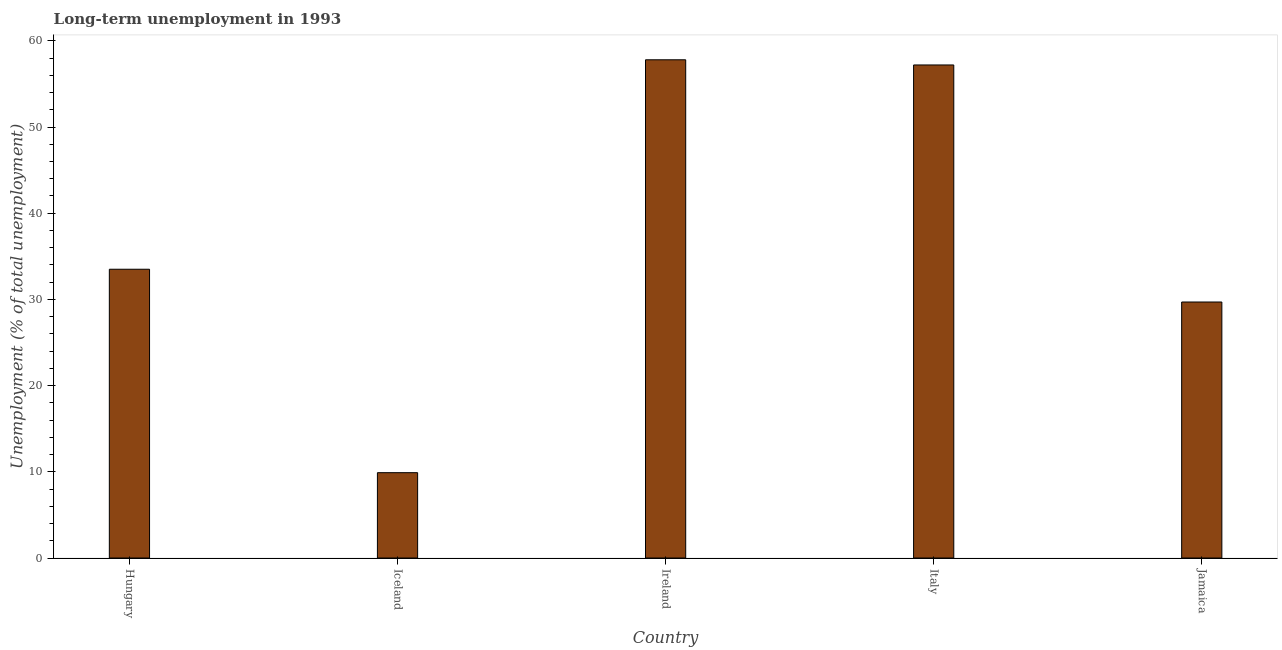Does the graph contain any zero values?
Offer a very short reply. No. Does the graph contain grids?
Your response must be concise. No. What is the title of the graph?
Your response must be concise. Long-term unemployment in 1993. What is the label or title of the X-axis?
Offer a terse response. Country. What is the label or title of the Y-axis?
Your response must be concise. Unemployment (% of total unemployment). What is the long-term unemployment in Jamaica?
Make the answer very short. 29.7. Across all countries, what is the maximum long-term unemployment?
Your answer should be very brief. 57.8. Across all countries, what is the minimum long-term unemployment?
Keep it short and to the point. 9.9. In which country was the long-term unemployment maximum?
Your answer should be very brief. Ireland. In which country was the long-term unemployment minimum?
Give a very brief answer. Iceland. What is the sum of the long-term unemployment?
Keep it short and to the point. 188.1. What is the difference between the long-term unemployment in Iceland and Italy?
Your response must be concise. -47.3. What is the average long-term unemployment per country?
Your response must be concise. 37.62. What is the median long-term unemployment?
Keep it short and to the point. 33.5. In how many countries, is the long-term unemployment greater than 18 %?
Your answer should be very brief. 4. What is the ratio of the long-term unemployment in Italy to that in Jamaica?
Make the answer very short. 1.93. What is the difference between the highest and the second highest long-term unemployment?
Provide a succinct answer. 0.6. Is the sum of the long-term unemployment in Hungary and Iceland greater than the maximum long-term unemployment across all countries?
Make the answer very short. No. What is the difference between the highest and the lowest long-term unemployment?
Ensure brevity in your answer.  47.9. In how many countries, is the long-term unemployment greater than the average long-term unemployment taken over all countries?
Make the answer very short. 2. How many countries are there in the graph?
Give a very brief answer. 5. What is the difference between two consecutive major ticks on the Y-axis?
Give a very brief answer. 10. What is the Unemployment (% of total unemployment) in Hungary?
Provide a short and direct response. 33.5. What is the Unemployment (% of total unemployment) of Iceland?
Your answer should be compact. 9.9. What is the Unemployment (% of total unemployment) of Ireland?
Provide a succinct answer. 57.8. What is the Unemployment (% of total unemployment) of Italy?
Make the answer very short. 57.2. What is the Unemployment (% of total unemployment) in Jamaica?
Keep it short and to the point. 29.7. What is the difference between the Unemployment (% of total unemployment) in Hungary and Iceland?
Give a very brief answer. 23.6. What is the difference between the Unemployment (% of total unemployment) in Hungary and Ireland?
Offer a very short reply. -24.3. What is the difference between the Unemployment (% of total unemployment) in Hungary and Italy?
Provide a succinct answer. -23.7. What is the difference between the Unemployment (% of total unemployment) in Hungary and Jamaica?
Provide a succinct answer. 3.8. What is the difference between the Unemployment (% of total unemployment) in Iceland and Ireland?
Make the answer very short. -47.9. What is the difference between the Unemployment (% of total unemployment) in Iceland and Italy?
Give a very brief answer. -47.3. What is the difference between the Unemployment (% of total unemployment) in Iceland and Jamaica?
Your response must be concise. -19.8. What is the difference between the Unemployment (% of total unemployment) in Ireland and Jamaica?
Offer a very short reply. 28.1. What is the difference between the Unemployment (% of total unemployment) in Italy and Jamaica?
Ensure brevity in your answer.  27.5. What is the ratio of the Unemployment (% of total unemployment) in Hungary to that in Iceland?
Your answer should be compact. 3.38. What is the ratio of the Unemployment (% of total unemployment) in Hungary to that in Ireland?
Keep it short and to the point. 0.58. What is the ratio of the Unemployment (% of total unemployment) in Hungary to that in Italy?
Offer a very short reply. 0.59. What is the ratio of the Unemployment (% of total unemployment) in Hungary to that in Jamaica?
Give a very brief answer. 1.13. What is the ratio of the Unemployment (% of total unemployment) in Iceland to that in Ireland?
Offer a very short reply. 0.17. What is the ratio of the Unemployment (% of total unemployment) in Iceland to that in Italy?
Offer a very short reply. 0.17. What is the ratio of the Unemployment (% of total unemployment) in Iceland to that in Jamaica?
Provide a short and direct response. 0.33. What is the ratio of the Unemployment (% of total unemployment) in Ireland to that in Italy?
Your answer should be compact. 1.01. What is the ratio of the Unemployment (% of total unemployment) in Ireland to that in Jamaica?
Your response must be concise. 1.95. What is the ratio of the Unemployment (% of total unemployment) in Italy to that in Jamaica?
Ensure brevity in your answer.  1.93. 